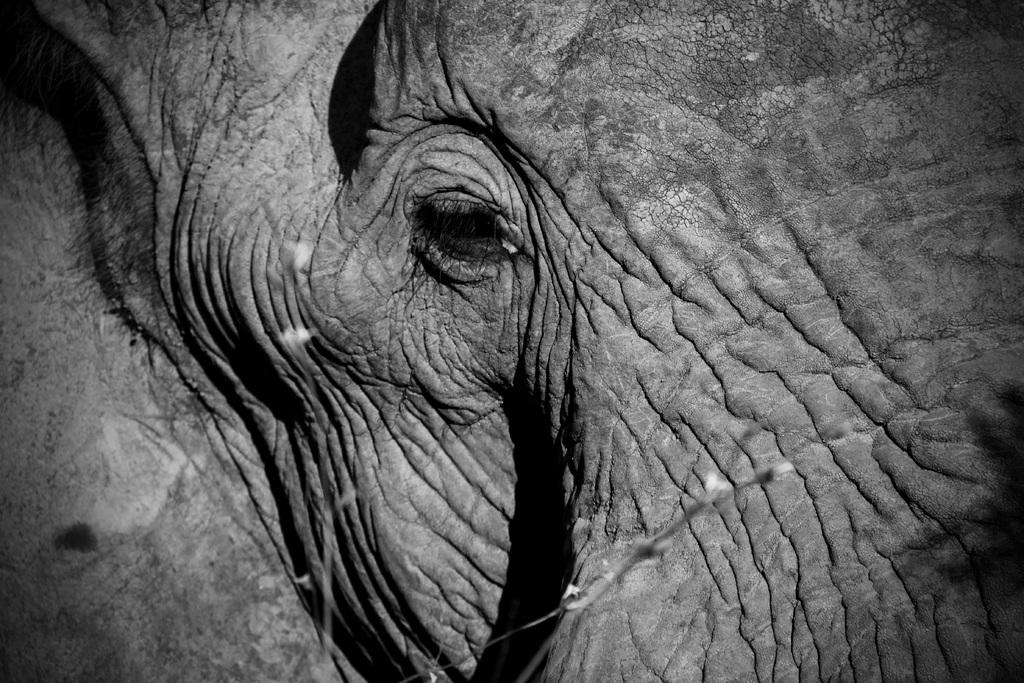What animal is the main subject of the image? There is an elephant in the image. How close is the view of the elephant in the image? The view of the elephant is close-up. What type of soap is the elephant using in the image? There is no soap present in the image, as it features an elephant with a close-up view. 